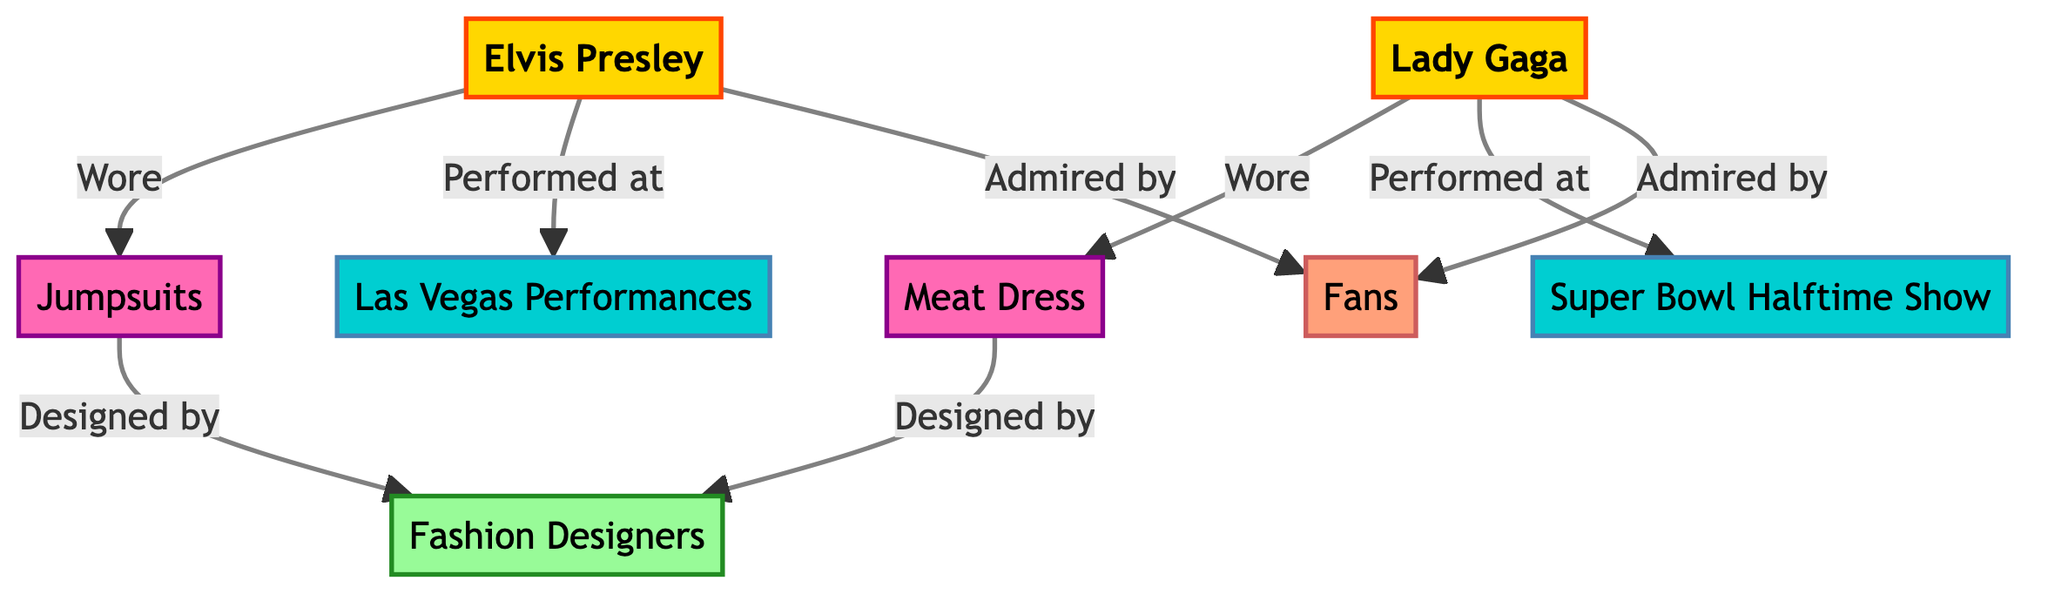What are the two iconic outfits shown in the diagram? The diagram lists two iconic outfits: Jumpsuits associated with Elvis Presley and the Meat Dress associated with Lady Gaga. These are clearly defined nodes in the diagram.
Answer: Jumpsuits, Meat Dress How many artists are represented in the diagram? The diagram features two main artists: Elvis Presley and Lady Gaga. These are represented as separate nodes.
Answer: 2 Which stage performance is associated with Elvis Presley? The diagram connects Elvis Presley to the "Las Vegas Performances" node through an edge labeled "Performed at." This indicates the specific stage performance related to him.
Answer: Las Vegas Performances Who designed both the Jumpsuits and the Meat Dress? Both iconic outfits (Jumpsuits and Meat Dress) are connected to "Fashion Designers" in the diagram, showing that they were designed by the same group.
Answer: Fashion Designers Which performance is Lady Gaga associated with in the diagram? The diagram connects Lady Gaga to the "Super Bowl Halftime Show" through an edge labeled "Performed at," indicating her association with that performance.
Answer: Super Bowl Halftime Show How are fans represented in relation to both artists? The diagram shows both Elvis Presley and Lady Gaga having a connection to "Fans" with edges labeled "Admired by." This indicates that both artists are admired by their respective fan bases.
Answer: Admired by What type of diagram is used to represent the influence of iconic stage performances? The data structure indicates a "Network Diagram," which showcases relationships between artists, outfits, performances, and influencers, highlighting their connections visually.
Answer: Network Diagram What is the relationship between Jumpsuits and Fashion Designers? The edge labeled "Designed by" connects the Jumpsuits node and Fashion Designers node, indicating that Jumpsuits were designed by Fashion Designers.
Answer: Designed by 